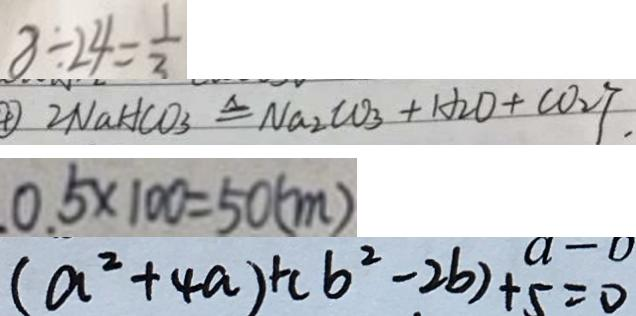<formula> <loc_0><loc_0><loc_500><loc_500>8 \div 2 4 = \frac { 1 } { 3 } 
 2 N a H C O _ { 3 } \Delta q N a _ { 2 } C O _ { 3 } + H _ { 2 } O + C O _ { 2 } \uparrow . 
 0 . 5 \times 1 0 0 = 5 0 ( m ) 
 ( a ^ { 2 } + 4 a ) + ( b ^ { 2 } - 2 b ) + 5 = 0</formula> 